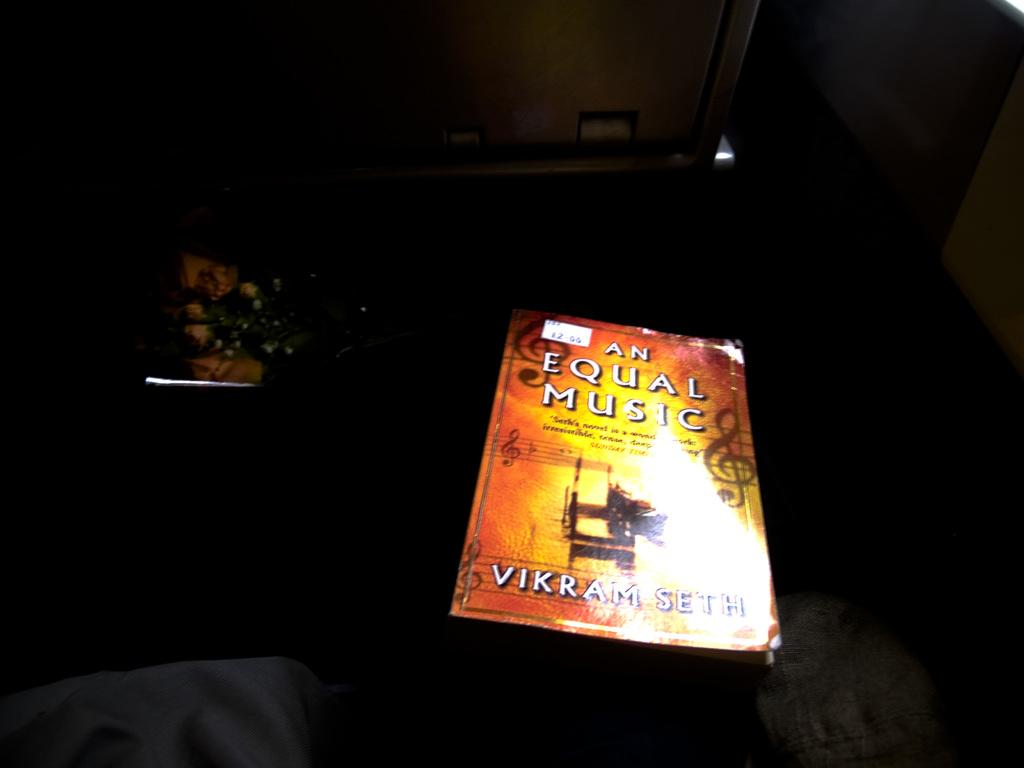<image>
Give a short and clear explanation of the subsequent image. An illuminated sign in a dark background reads "An Equal Music." 